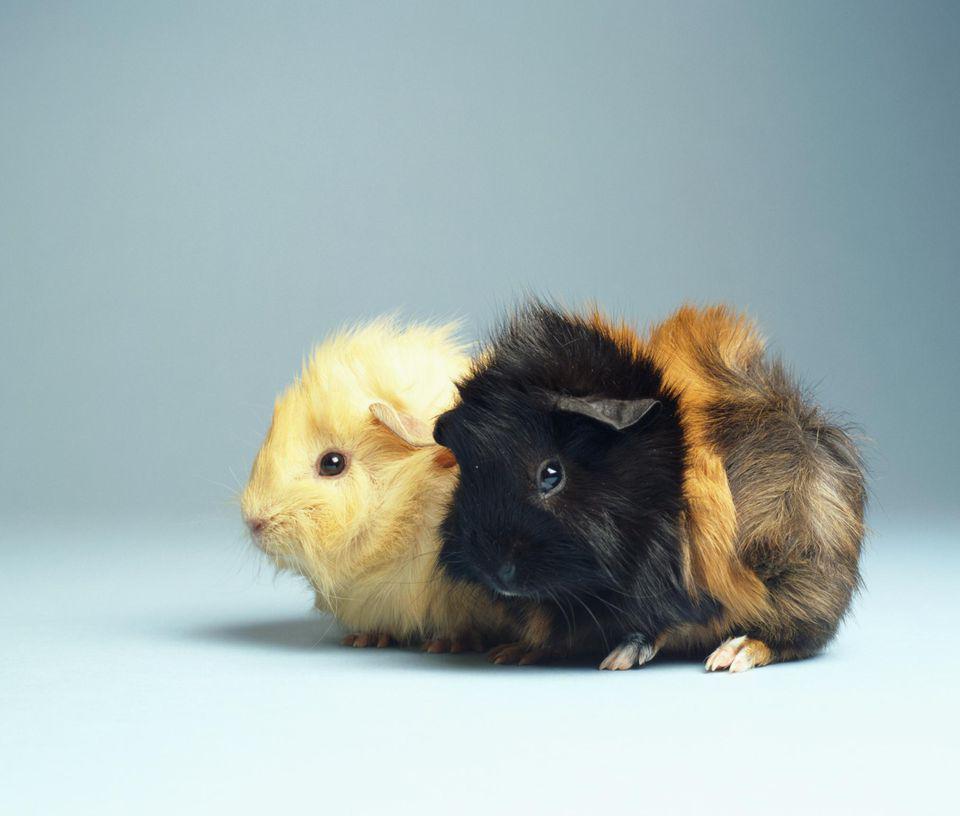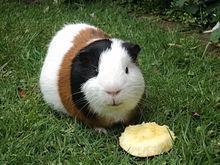The first image is the image on the left, the second image is the image on the right. For the images shown, is this caption "The right image shows two guinea pigs and the left shows only one, and one of the images includes a bright orange object." true? Answer yes or no. No. The first image is the image on the left, the second image is the image on the right. Assess this claim about the two images: "There is at least one rodent sitting on the grass in the image on the right.". Correct or not? Answer yes or no. Yes. 